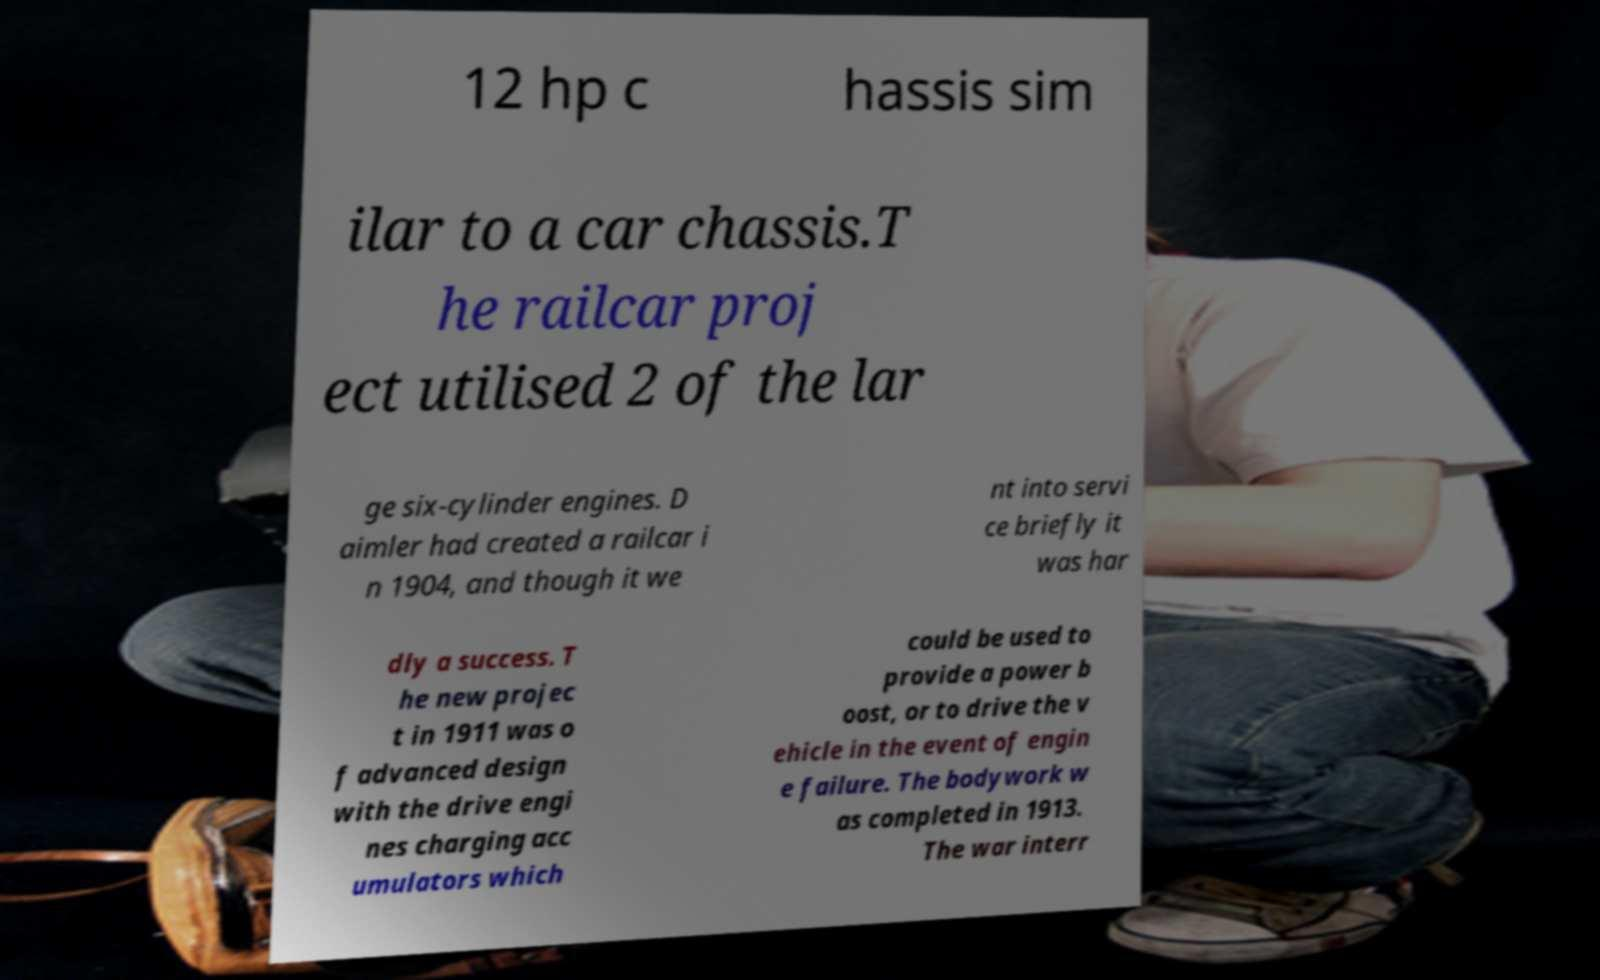Can you accurately transcribe the text from the provided image for me? 12 hp c hassis sim ilar to a car chassis.T he railcar proj ect utilised 2 of the lar ge six-cylinder engines. D aimler had created a railcar i n 1904, and though it we nt into servi ce briefly it was har dly a success. T he new projec t in 1911 was o f advanced design with the drive engi nes charging acc umulators which could be used to provide a power b oost, or to drive the v ehicle in the event of engin e failure. The bodywork w as completed in 1913. The war interr 